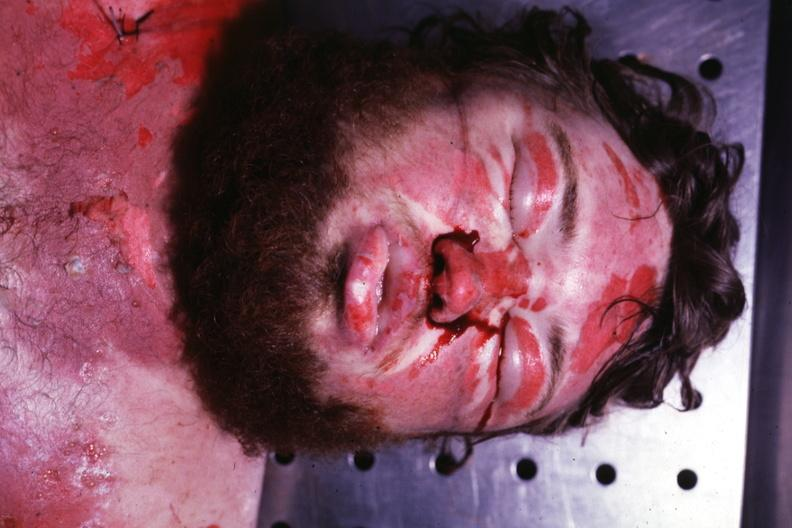what is present?
Answer the question using a single word or phrase. Face 